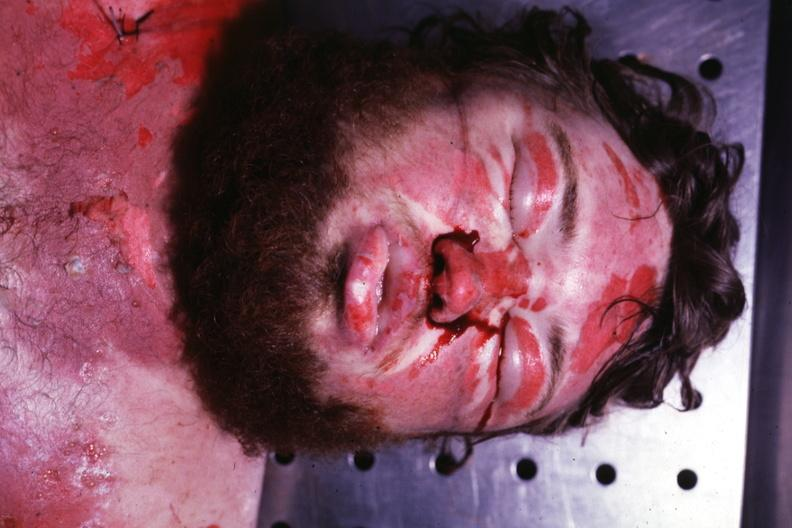what is present?
Answer the question using a single word or phrase. Face 